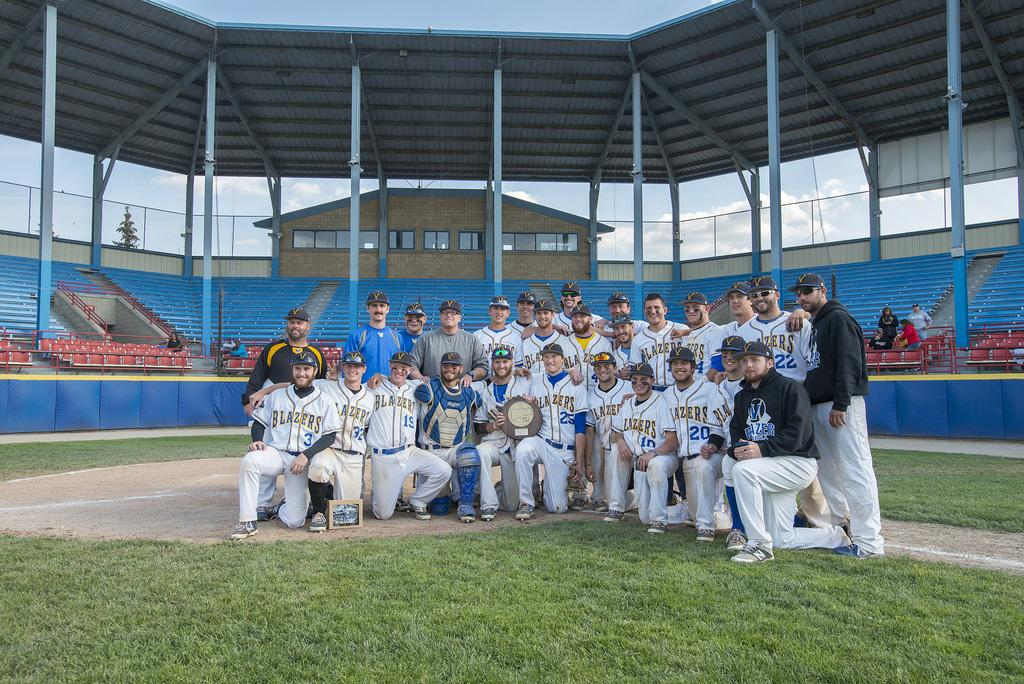<image>
Summarize the visual content of the image. Lazers Jersey with numbers ten, nineteen, and thirty two designed on them. 